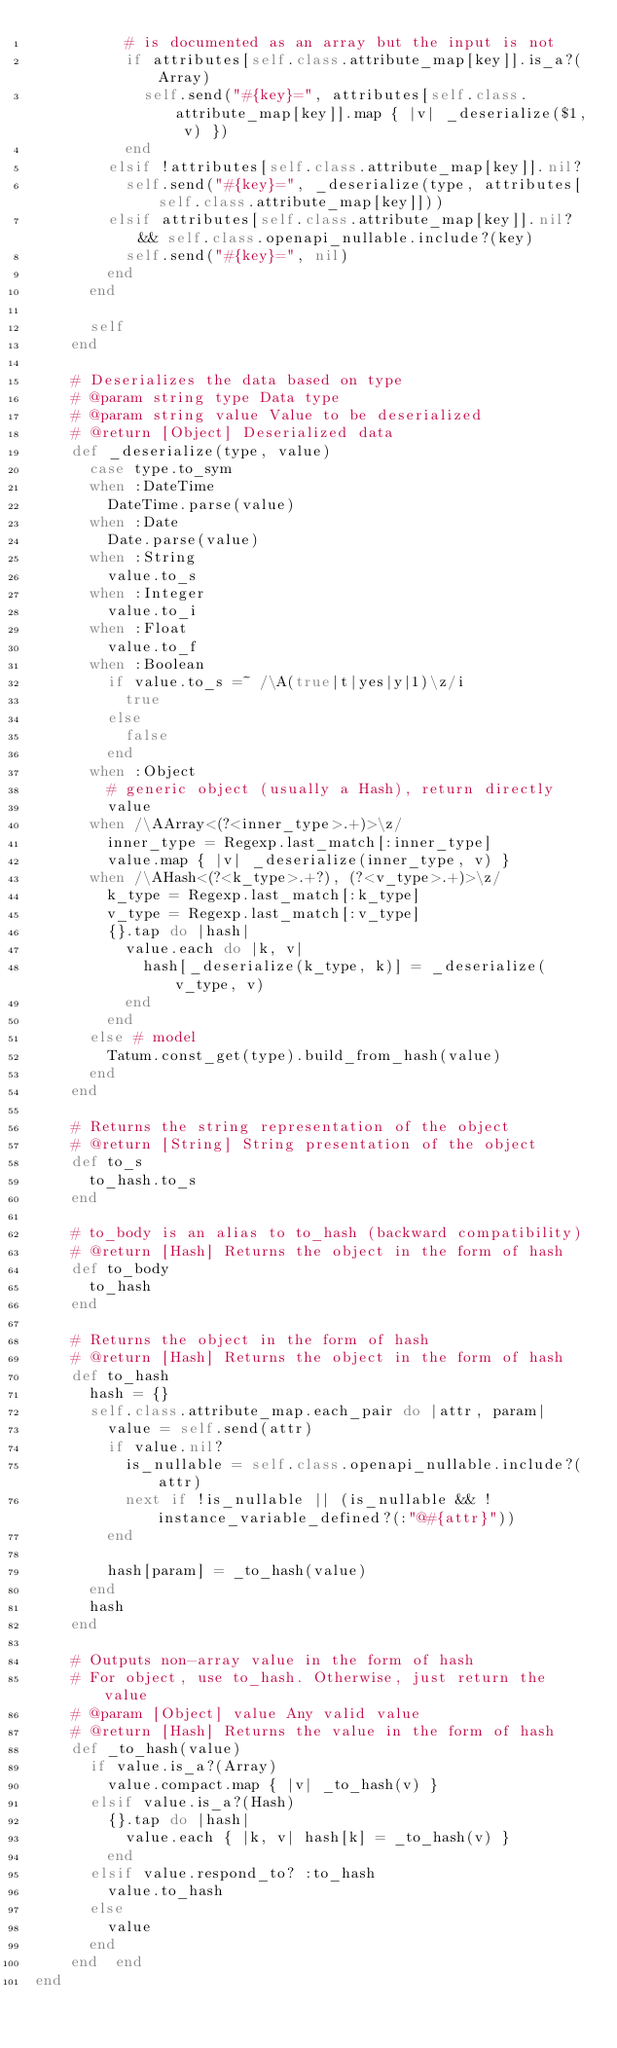<code> <loc_0><loc_0><loc_500><loc_500><_Ruby_>          # is documented as an array but the input is not
          if attributes[self.class.attribute_map[key]].is_a?(Array)
            self.send("#{key}=", attributes[self.class.attribute_map[key]].map { |v| _deserialize($1, v) })
          end
        elsif !attributes[self.class.attribute_map[key]].nil?
          self.send("#{key}=", _deserialize(type, attributes[self.class.attribute_map[key]]))
        elsif attributes[self.class.attribute_map[key]].nil? && self.class.openapi_nullable.include?(key)
          self.send("#{key}=", nil)
        end
      end

      self
    end

    # Deserializes the data based on type
    # @param string type Data type
    # @param string value Value to be deserialized
    # @return [Object] Deserialized data
    def _deserialize(type, value)
      case type.to_sym
      when :DateTime
        DateTime.parse(value)
      when :Date
        Date.parse(value)
      when :String
        value.to_s
      when :Integer
        value.to_i
      when :Float
        value.to_f
      when :Boolean
        if value.to_s =~ /\A(true|t|yes|y|1)\z/i
          true
        else
          false
        end
      when :Object
        # generic object (usually a Hash), return directly
        value
      when /\AArray<(?<inner_type>.+)>\z/
        inner_type = Regexp.last_match[:inner_type]
        value.map { |v| _deserialize(inner_type, v) }
      when /\AHash<(?<k_type>.+?), (?<v_type>.+)>\z/
        k_type = Regexp.last_match[:k_type]
        v_type = Regexp.last_match[:v_type]
        {}.tap do |hash|
          value.each do |k, v|
            hash[_deserialize(k_type, k)] = _deserialize(v_type, v)
          end
        end
      else # model
        Tatum.const_get(type).build_from_hash(value)
      end
    end

    # Returns the string representation of the object
    # @return [String] String presentation of the object
    def to_s
      to_hash.to_s
    end

    # to_body is an alias to to_hash (backward compatibility)
    # @return [Hash] Returns the object in the form of hash
    def to_body
      to_hash
    end

    # Returns the object in the form of hash
    # @return [Hash] Returns the object in the form of hash
    def to_hash
      hash = {}
      self.class.attribute_map.each_pair do |attr, param|
        value = self.send(attr)
        if value.nil?
          is_nullable = self.class.openapi_nullable.include?(attr)
          next if !is_nullable || (is_nullable && !instance_variable_defined?(:"@#{attr}"))
        end

        hash[param] = _to_hash(value)
      end
      hash
    end

    # Outputs non-array value in the form of hash
    # For object, use to_hash. Otherwise, just return the value
    # @param [Object] value Any valid value
    # @return [Hash] Returns the value in the form of hash
    def _to_hash(value)
      if value.is_a?(Array)
        value.compact.map { |v| _to_hash(v) }
      elsif value.is_a?(Hash)
        {}.tap do |hash|
          value.each { |k, v| hash[k] = _to_hash(v) }
        end
      elsif value.respond_to? :to_hash
        value.to_hash
      else
        value
      end
    end  end
end
</code> 